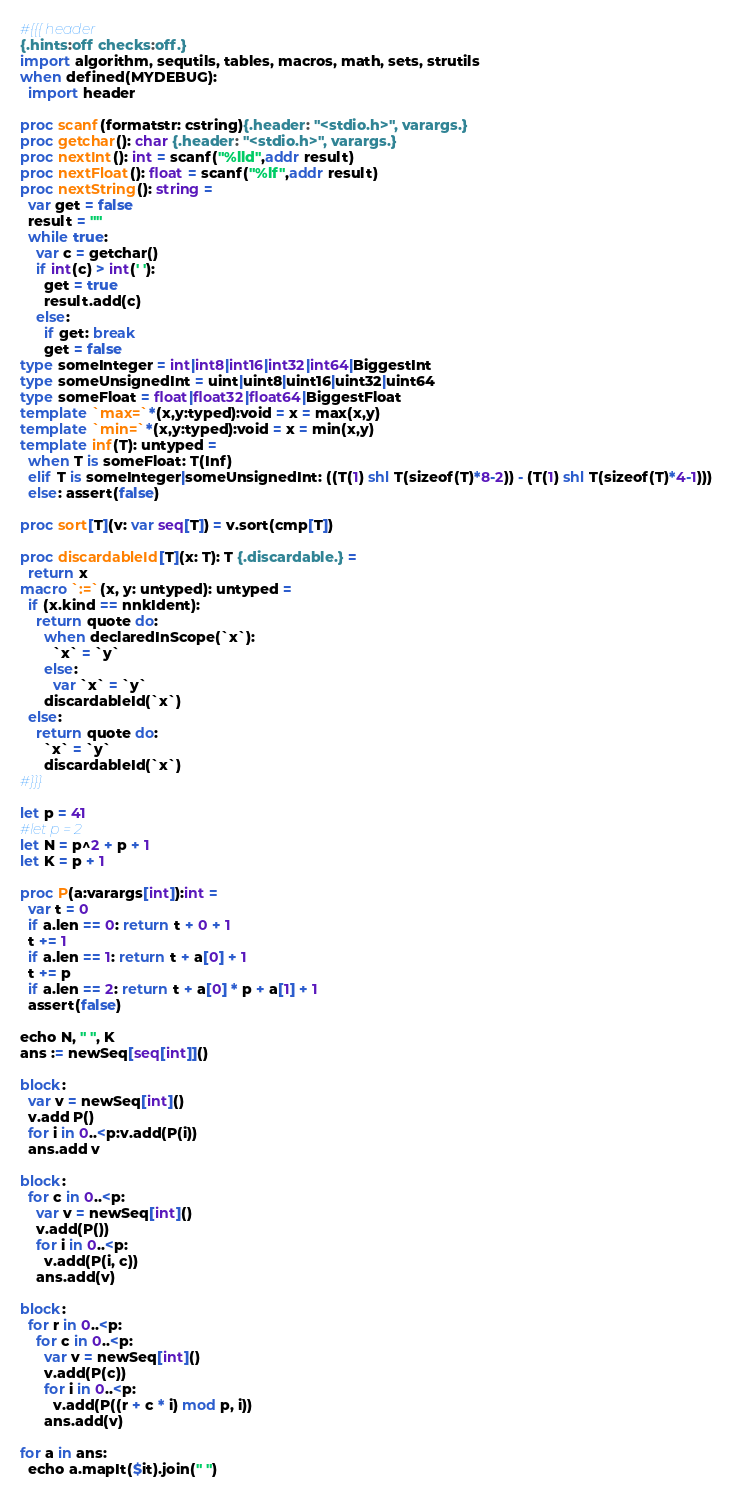<code> <loc_0><loc_0><loc_500><loc_500><_Nim_>#{{{ header
{.hints:off checks:off.}
import algorithm, sequtils, tables, macros, math, sets, strutils
when defined(MYDEBUG):
  import header

proc scanf(formatstr: cstring){.header: "<stdio.h>", varargs.}
proc getchar(): char {.header: "<stdio.h>", varargs.}
proc nextInt(): int = scanf("%lld",addr result)
proc nextFloat(): float = scanf("%lf",addr result)
proc nextString(): string =
  var get = false
  result = ""
  while true:
    var c = getchar()
    if int(c) > int(' '):
      get = true
      result.add(c)
    else:
      if get: break
      get = false
type someInteger = int|int8|int16|int32|int64|BiggestInt
type someUnsignedInt = uint|uint8|uint16|uint32|uint64
type someFloat = float|float32|float64|BiggestFloat
template `max=`*(x,y:typed):void = x = max(x,y)
template `min=`*(x,y:typed):void = x = min(x,y)
template inf(T): untyped = 
  when T is someFloat: T(Inf)
  elif T is someInteger|someUnsignedInt: ((T(1) shl T(sizeof(T)*8-2)) - (T(1) shl T(sizeof(T)*4-1)))
  else: assert(false)

proc sort[T](v: var seq[T]) = v.sort(cmp[T])

proc discardableId[T](x: T): T {.discardable.} =
  return x
macro `:=`(x, y: untyped): untyped =
  if (x.kind == nnkIdent):
    return quote do:
      when declaredInScope(`x`):
        `x` = `y`
      else:
        var `x` = `y`
      discardableId(`x`)
  else:
    return quote do:
      `x` = `y`
      discardableId(`x`)
#}}}

let p = 41
#let p = 2
let N = p^2 + p + 1
let K = p + 1

proc P(a:varargs[int]):int =
  var t = 0
  if a.len == 0: return t + 0 + 1
  t += 1
  if a.len == 1: return t + a[0] + 1
  t += p
  if a.len == 2: return t + a[0] * p + a[1] + 1
  assert(false)

echo N, " ", K
ans := newSeq[seq[int]]()

block:
  var v = newSeq[int]()
  v.add P()
  for i in 0..<p:v.add(P(i))
  ans.add v

block:
  for c in 0..<p:
    var v = newSeq[int]()
    v.add(P())
    for i in 0..<p:
      v.add(P(i, c))
    ans.add(v)

block:
  for r in 0..<p:
    for c in 0..<p:
      var v = newSeq[int]()
      v.add(P(c))
      for i in 0..<p:
        v.add(P((r + c * i) mod p, i))
      ans.add(v)

for a in ans:
  echo a.mapIt($it).join(" ")</code> 